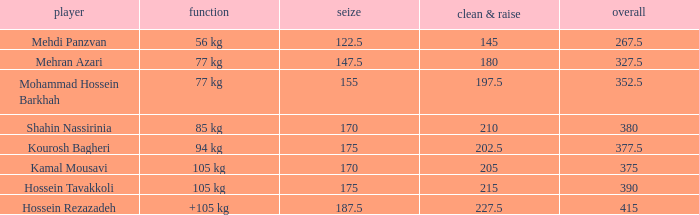What event has a 122.5 snatch rate? 56 kg. 